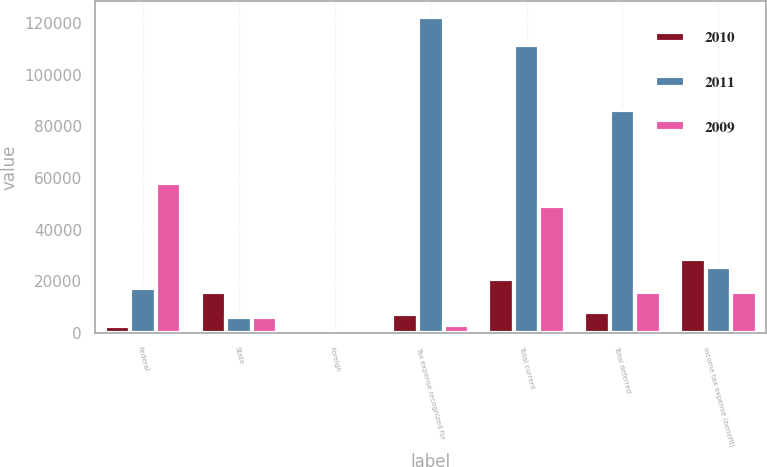Convert chart to OTSL. <chart><loc_0><loc_0><loc_500><loc_500><stacked_bar_chart><ecel><fcel>Federal<fcel>State<fcel>Foreign<fcel>Tax expense recognized for<fcel>Total current<fcel>Total deferred<fcel>Income tax expense (benefit)<nl><fcel>2010<fcel>2645<fcel>15651<fcel>523<fcel>7205<fcel>20734<fcel>7895<fcel>28629<nl><fcel>2011<fcel>17393<fcel>6092<fcel>448<fcel>122383<fcel>111530<fcel>86199<fcel>25331<nl><fcel>2009<fcel>58042<fcel>6049<fcel>24<fcel>2989<fcel>48980<fcel>15651<fcel>15651<nl></chart> 